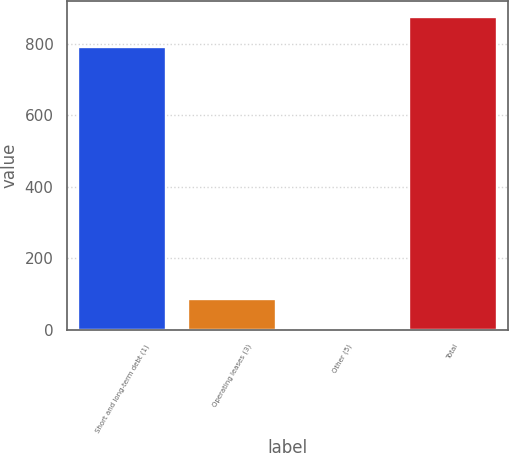Convert chart to OTSL. <chart><loc_0><loc_0><loc_500><loc_500><bar_chart><fcel>Short and long-term debt (1)<fcel>Operating leases (3)<fcel>Other (5)<fcel>Total<nl><fcel>791.9<fcel>87.33<fcel>4.9<fcel>874.33<nl></chart> 